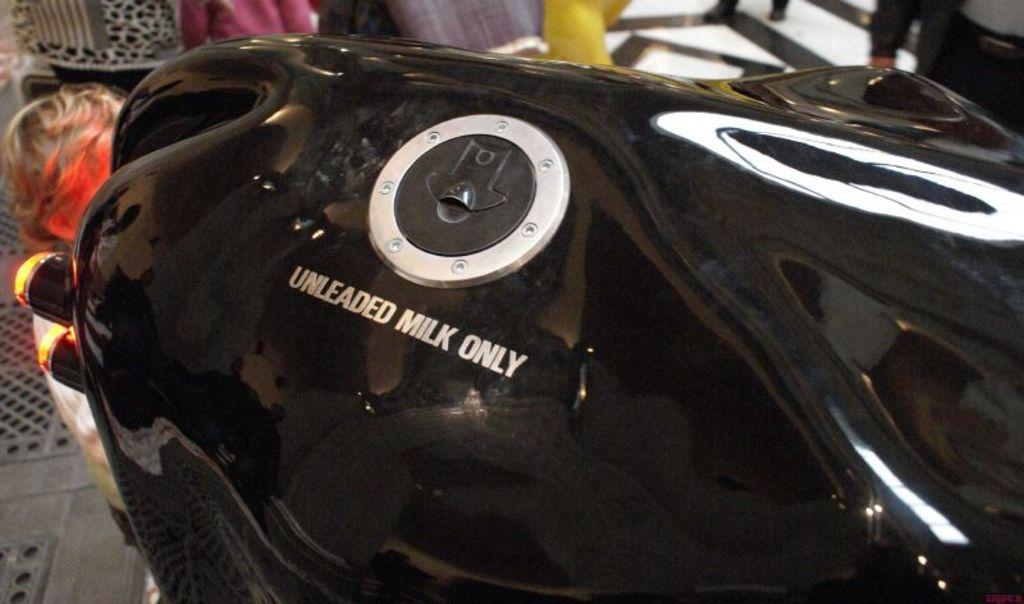What type of object is in the image? There is a metal tank in the image. Who or what is present in the image besides the metal tank? There is a kid standing in the image. What type of vessel is the kid sailing in the image? There is no vessel present in the image, and the kid is not sailing. 